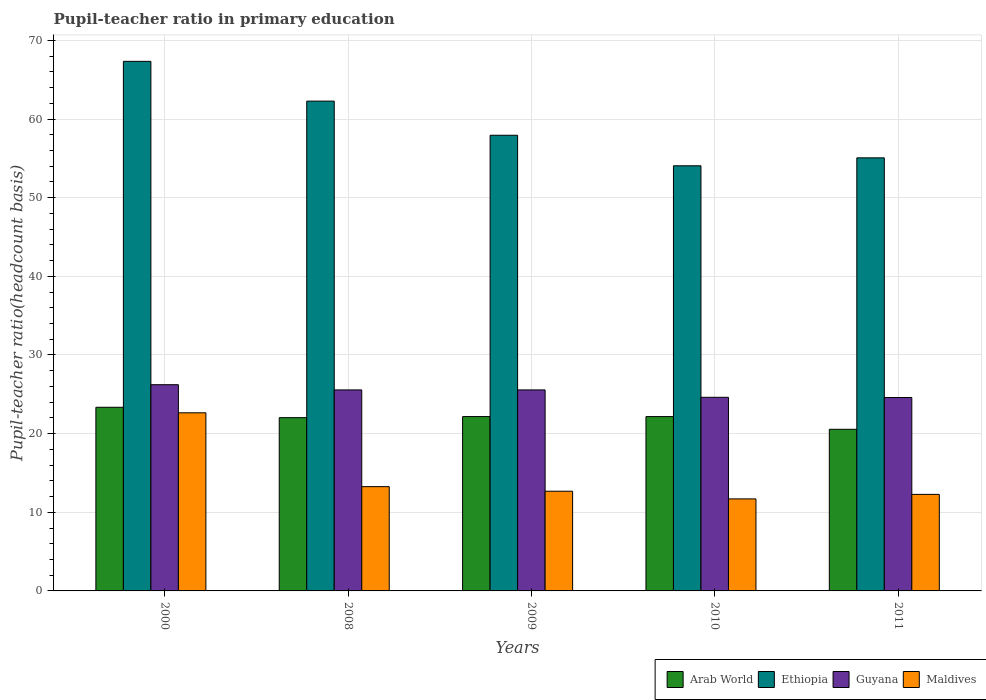How many different coloured bars are there?
Give a very brief answer. 4. How many groups of bars are there?
Ensure brevity in your answer.  5. How many bars are there on the 1st tick from the left?
Your answer should be compact. 4. What is the label of the 2nd group of bars from the left?
Provide a succinct answer. 2008. What is the pupil-teacher ratio in primary education in Guyana in 2008?
Offer a very short reply. 25.56. Across all years, what is the maximum pupil-teacher ratio in primary education in Ethiopia?
Ensure brevity in your answer.  67.34. Across all years, what is the minimum pupil-teacher ratio in primary education in Maldives?
Your answer should be very brief. 11.7. What is the total pupil-teacher ratio in primary education in Maldives in the graph?
Provide a short and direct response. 72.56. What is the difference between the pupil-teacher ratio in primary education in Ethiopia in 2000 and that in 2010?
Ensure brevity in your answer.  13.28. What is the difference between the pupil-teacher ratio in primary education in Ethiopia in 2008 and the pupil-teacher ratio in primary education in Maldives in 2009?
Your answer should be very brief. 49.61. What is the average pupil-teacher ratio in primary education in Maldives per year?
Make the answer very short. 14.51. In the year 2009, what is the difference between the pupil-teacher ratio in primary education in Ethiopia and pupil-teacher ratio in primary education in Arab World?
Your answer should be compact. 35.77. In how many years, is the pupil-teacher ratio in primary education in Guyana greater than 50?
Give a very brief answer. 0. What is the ratio of the pupil-teacher ratio in primary education in Arab World in 2000 to that in 2009?
Provide a succinct answer. 1.05. What is the difference between the highest and the second highest pupil-teacher ratio in primary education in Ethiopia?
Your answer should be compact. 5.06. What is the difference between the highest and the lowest pupil-teacher ratio in primary education in Arab World?
Your response must be concise. 2.8. In how many years, is the pupil-teacher ratio in primary education in Arab World greater than the average pupil-teacher ratio in primary education in Arab World taken over all years?
Your answer should be compact. 3. Is the sum of the pupil-teacher ratio in primary education in Arab World in 2009 and 2011 greater than the maximum pupil-teacher ratio in primary education in Ethiopia across all years?
Your answer should be compact. No. Is it the case that in every year, the sum of the pupil-teacher ratio in primary education in Ethiopia and pupil-teacher ratio in primary education in Maldives is greater than the sum of pupil-teacher ratio in primary education in Guyana and pupil-teacher ratio in primary education in Arab World?
Your answer should be compact. Yes. What does the 3rd bar from the left in 2011 represents?
Your answer should be very brief. Guyana. What does the 1st bar from the right in 2010 represents?
Keep it short and to the point. Maldives. Is it the case that in every year, the sum of the pupil-teacher ratio in primary education in Guyana and pupil-teacher ratio in primary education in Maldives is greater than the pupil-teacher ratio in primary education in Arab World?
Offer a terse response. Yes. How many bars are there?
Your response must be concise. 20. What is the difference between two consecutive major ticks on the Y-axis?
Ensure brevity in your answer.  10. Are the values on the major ticks of Y-axis written in scientific E-notation?
Provide a succinct answer. No. Does the graph contain grids?
Give a very brief answer. Yes. How are the legend labels stacked?
Keep it short and to the point. Horizontal. What is the title of the graph?
Offer a terse response. Pupil-teacher ratio in primary education. Does "Greece" appear as one of the legend labels in the graph?
Provide a short and direct response. No. What is the label or title of the X-axis?
Keep it short and to the point. Years. What is the label or title of the Y-axis?
Ensure brevity in your answer.  Pupil-teacher ratio(headcount basis). What is the Pupil-teacher ratio(headcount basis) of Arab World in 2000?
Provide a short and direct response. 23.35. What is the Pupil-teacher ratio(headcount basis) of Ethiopia in 2000?
Your answer should be compact. 67.34. What is the Pupil-teacher ratio(headcount basis) of Guyana in 2000?
Provide a succinct answer. 26.22. What is the Pupil-teacher ratio(headcount basis) in Maldives in 2000?
Ensure brevity in your answer.  22.65. What is the Pupil-teacher ratio(headcount basis) in Arab World in 2008?
Offer a very short reply. 22.03. What is the Pupil-teacher ratio(headcount basis) of Ethiopia in 2008?
Provide a succinct answer. 62.28. What is the Pupil-teacher ratio(headcount basis) in Guyana in 2008?
Keep it short and to the point. 25.56. What is the Pupil-teacher ratio(headcount basis) of Maldives in 2008?
Provide a succinct answer. 13.26. What is the Pupil-teacher ratio(headcount basis) of Arab World in 2009?
Your answer should be compact. 22.17. What is the Pupil-teacher ratio(headcount basis) in Ethiopia in 2009?
Ensure brevity in your answer.  57.94. What is the Pupil-teacher ratio(headcount basis) in Guyana in 2009?
Make the answer very short. 25.56. What is the Pupil-teacher ratio(headcount basis) of Maldives in 2009?
Provide a short and direct response. 12.68. What is the Pupil-teacher ratio(headcount basis) in Arab World in 2010?
Keep it short and to the point. 22.17. What is the Pupil-teacher ratio(headcount basis) in Ethiopia in 2010?
Offer a terse response. 54.06. What is the Pupil-teacher ratio(headcount basis) of Guyana in 2010?
Provide a short and direct response. 24.62. What is the Pupil-teacher ratio(headcount basis) in Maldives in 2010?
Give a very brief answer. 11.7. What is the Pupil-teacher ratio(headcount basis) in Arab World in 2011?
Give a very brief answer. 20.55. What is the Pupil-teacher ratio(headcount basis) of Ethiopia in 2011?
Make the answer very short. 55.07. What is the Pupil-teacher ratio(headcount basis) in Guyana in 2011?
Provide a succinct answer. 24.59. What is the Pupil-teacher ratio(headcount basis) of Maldives in 2011?
Keep it short and to the point. 12.28. Across all years, what is the maximum Pupil-teacher ratio(headcount basis) of Arab World?
Offer a very short reply. 23.35. Across all years, what is the maximum Pupil-teacher ratio(headcount basis) of Ethiopia?
Your answer should be compact. 67.34. Across all years, what is the maximum Pupil-teacher ratio(headcount basis) in Guyana?
Provide a succinct answer. 26.22. Across all years, what is the maximum Pupil-teacher ratio(headcount basis) in Maldives?
Give a very brief answer. 22.65. Across all years, what is the minimum Pupil-teacher ratio(headcount basis) of Arab World?
Offer a very short reply. 20.55. Across all years, what is the minimum Pupil-teacher ratio(headcount basis) in Ethiopia?
Ensure brevity in your answer.  54.06. Across all years, what is the minimum Pupil-teacher ratio(headcount basis) in Guyana?
Provide a succinct answer. 24.59. Across all years, what is the minimum Pupil-teacher ratio(headcount basis) in Maldives?
Your answer should be compact. 11.7. What is the total Pupil-teacher ratio(headcount basis) in Arab World in the graph?
Offer a very short reply. 110.28. What is the total Pupil-teacher ratio(headcount basis) in Ethiopia in the graph?
Your answer should be compact. 296.69. What is the total Pupil-teacher ratio(headcount basis) of Guyana in the graph?
Ensure brevity in your answer.  126.56. What is the total Pupil-teacher ratio(headcount basis) of Maldives in the graph?
Your response must be concise. 72.56. What is the difference between the Pupil-teacher ratio(headcount basis) of Arab World in 2000 and that in 2008?
Your response must be concise. 1.32. What is the difference between the Pupil-teacher ratio(headcount basis) in Ethiopia in 2000 and that in 2008?
Provide a succinct answer. 5.06. What is the difference between the Pupil-teacher ratio(headcount basis) of Guyana in 2000 and that in 2008?
Offer a terse response. 0.66. What is the difference between the Pupil-teacher ratio(headcount basis) in Maldives in 2000 and that in 2008?
Offer a very short reply. 9.39. What is the difference between the Pupil-teacher ratio(headcount basis) in Arab World in 2000 and that in 2009?
Make the answer very short. 1.18. What is the difference between the Pupil-teacher ratio(headcount basis) of Ethiopia in 2000 and that in 2009?
Ensure brevity in your answer.  9.4. What is the difference between the Pupil-teacher ratio(headcount basis) of Guyana in 2000 and that in 2009?
Your answer should be very brief. 0.66. What is the difference between the Pupil-teacher ratio(headcount basis) in Maldives in 2000 and that in 2009?
Provide a succinct answer. 9.97. What is the difference between the Pupil-teacher ratio(headcount basis) in Arab World in 2000 and that in 2010?
Offer a very short reply. 1.19. What is the difference between the Pupil-teacher ratio(headcount basis) in Ethiopia in 2000 and that in 2010?
Offer a terse response. 13.28. What is the difference between the Pupil-teacher ratio(headcount basis) of Guyana in 2000 and that in 2010?
Offer a terse response. 1.6. What is the difference between the Pupil-teacher ratio(headcount basis) of Maldives in 2000 and that in 2010?
Your answer should be very brief. 10.95. What is the difference between the Pupil-teacher ratio(headcount basis) in Arab World in 2000 and that in 2011?
Your answer should be very brief. 2.8. What is the difference between the Pupil-teacher ratio(headcount basis) of Ethiopia in 2000 and that in 2011?
Offer a very short reply. 12.27. What is the difference between the Pupil-teacher ratio(headcount basis) in Guyana in 2000 and that in 2011?
Your response must be concise. 1.63. What is the difference between the Pupil-teacher ratio(headcount basis) of Maldives in 2000 and that in 2011?
Provide a short and direct response. 10.37. What is the difference between the Pupil-teacher ratio(headcount basis) in Arab World in 2008 and that in 2009?
Provide a short and direct response. -0.14. What is the difference between the Pupil-teacher ratio(headcount basis) of Ethiopia in 2008 and that in 2009?
Your answer should be compact. 4.34. What is the difference between the Pupil-teacher ratio(headcount basis) in Guyana in 2008 and that in 2009?
Provide a short and direct response. -0. What is the difference between the Pupil-teacher ratio(headcount basis) of Maldives in 2008 and that in 2009?
Offer a terse response. 0.58. What is the difference between the Pupil-teacher ratio(headcount basis) in Arab World in 2008 and that in 2010?
Provide a short and direct response. -0.14. What is the difference between the Pupil-teacher ratio(headcount basis) of Ethiopia in 2008 and that in 2010?
Offer a terse response. 8.22. What is the difference between the Pupil-teacher ratio(headcount basis) in Guyana in 2008 and that in 2010?
Provide a succinct answer. 0.94. What is the difference between the Pupil-teacher ratio(headcount basis) of Maldives in 2008 and that in 2010?
Your answer should be very brief. 1.56. What is the difference between the Pupil-teacher ratio(headcount basis) in Arab World in 2008 and that in 2011?
Keep it short and to the point. 1.48. What is the difference between the Pupil-teacher ratio(headcount basis) in Ethiopia in 2008 and that in 2011?
Ensure brevity in your answer.  7.21. What is the difference between the Pupil-teacher ratio(headcount basis) of Guyana in 2008 and that in 2011?
Keep it short and to the point. 0.97. What is the difference between the Pupil-teacher ratio(headcount basis) of Maldives in 2008 and that in 2011?
Provide a succinct answer. 0.98. What is the difference between the Pupil-teacher ratio(headcount basis) of Arab World in 2009 and that in 2010?
Offer a terse response. 0. What is the difference between the Pupil-teacher ratio(headcount basis) in Ethiopia in 2009 and that in 2010?
Provide a short and direct response. 3.88. What is the difference between the Pupil-teacher ratio(headcount basis) of Maldives in 2009 and that in 2010?
Offer a terse response. 0.98. What is the difference between the Pupil-teacher ratio(headcount basis) in Arab World in 2009 and that in 2011?
Ensure brevity in your answer.  1.62. What is the difference between the Pupil-teacher ratio(headcount basis) in Ethiopia in 2009 and that in 2011?
Offer a very short reply. 2.87. What is the difference between the Pupil-teacher ratio(headcount basis) in Guyana in 2009 and that in 2011?
Make the answer very short. 0.97. What is the difference between the Pupil-teacher ratio(headcount basis) in Maldives in 2009 and that in 2011?
Offer a terse response. 0.4. What is the difference between the Pupil-teacher ratio(headcount basis) in Arab World in 2010 and that in 2011?
Ensure brevity in your answer.  1.61. What is the difference between the Pupil-teacher ratio(headcount basis) in Ethiopia in 2010 and that in 2011?
Offer a very short reply. -1.01. What is the difference between the Pupil-teacher ratio(headcount basis) in Guyana in 2010 and that in 2011?
Make the answer very short. 0.03. What is the difference between the Pupil-teacher ratio(headcount basis) of Maldives in 2010 and that in 2011?
Offer a terse response. -0.57. What is the difference between the Pupil-teacher ratio(headcount basis) in Arab World in 2000 and the Pupil-teacher ratio(headcount basis) in Ethiopia in 2008?
Offer a very short reply. -38.93. What is the difference between the Pupil-teacher ratio(headcount basis) of Arab World in 2000 and the Pupil-teacher ratio(headcount basis) of Guyana in 2008?
Your answer should be compact. -2.21. What is the difference between the Pupil-teacher ratio(headcount basis) of Arab World in 2000 and the Pupil-teacher ratio(headcount basis) of Maldives in 2008?
Your answer should be very brief. 10.09. What is the difference between the Pupil-teacher ratio(headcount basis) in Ethiopia in 2000 and the Pupil-teacher ratio(headcount basis) in Guyana in 2008?
Offer a terse response. 41.78. What is the difference between the Pupil-teacher ratio(headcount basis) in Ethiopia in 2000 and the Pupil-teacher ratio(headcount basis) in Maldives in 2008?
Ensure brevity in your answer.  54.08. What is the difference between the Pupil-teacher ratio(headcount basis) in Guyana in 2000 and the Pupil-teacher ratio(headcount basis) in Maldives in 2008?
Your response must be concise. 12.97. What is the difference between the Pupil-teacher ratio(headcount basis) in Arab World in 2000 and the Pupil-teacher ratio(headcount basis) in Ethiopia in 2009?
Keep it short and to the point. -34.59. What is the difference between the Pupil-teacher ratio(headcount basis) in Arab World in 2000 and the Pupil-teacher ratio(headcount basis) in Guyana in 2009?
Provide a short and direct response. -2.21. What is the difference between the Pupil-teacher ratio(headcount basis) of Arab World in 2000 and the Pupil-teacher ratio(headcount basis) of Maldives in 2009?
Keep it short and to the point. 10.68. What is the difference between the Pupil-teacher ratio(headcount basis) in Ethiopia in 2000 and the Pupil-teacher ratio(headcount basis) in Guyana in 2009?
Offer a terse response. 41.78. What is the difference between the Pupil-teacher ratio(headcount basis) of Ethiopia in 2000 and the Pupil-teacher ratio(headcount basis) of Maldives in 2009?
Keep it short and to the point. 54.66. What is the difference between the Pupil-teacher ratio(headcount basis) of Guyana in 2000 and the Pupil-teacher ratio(headcount basis) of Maldives in 2009?
Offer a terse response. 13.55. What is the difference between the Pupil-teacher ratio(headcount basis) in Arab World in 2000 and the Pupil-teacher ratio(headcount basis) in Ethiopia in 2010?
Your response must be concise. -30.71. What is the difference between the Pupil-teacher ratio(headcount basis) of Arab World in 2000 and the Pupil-teacher ratio(headcount basis) of Guyana in 2010?
Provide a short and direct response. -1.27. What is the difference between the Pupil-teacher ratio(headcount basis) of Arab World in 2000 and the Pupil-teacher ratio(headcount basis) of Maldives in 2010?
Provide a succinct answer. 11.65. What is the difference between the Pupil-teacher ratio(headcount basis) in Ethiopia in 2000 and the Pupil-teacher ratio(headcount basis) in Guyana in 2010?
Offer a terse response. 42.72. What is the difference between the Pupil-teacher ratio(headcount basis) in Ethiopia in 2000 and the Pupil-teacher ratio(headcount basis) in Maldives in 2010?
Your answer should be compact. 55.64. What is the difference between the Pupil-teacher ratio(headcount basis) in Guyana in 2000 and the Pupil-teacher ratio(headcount basis) in Maldives in 2010?
Provide a short and direct response. 14.52. What is the difference between the Pupil-teacher ratio(headcount basis) of Arab World in 2000 and the Pupil-teacher ratio(headcount basis) of Ethiopia in 2011?
Offer a terse response. -31.72. What is the difference between the Pupil-teacher ratio(headcount basis) in Arab World in 2000 and the Pupil-teacher ratio(headcount basis) in Guyana in 2011?
Give a very brief answer. -1.24. What is the difference between the Pupil-teacher ratio(headcount basis) of Arab World in 2000 and the Pupil-teacher ratio(headcount basis) of Maldives in 2011?
Keep it short and to the point. 11.08. What is the difference between the Pupil-teacher ratio(headcount basis) in Ethiopia in 2000 and the Pupil-teacher ratio(headcount basis) in Guyana in 2011?
Your response must be concise. 42.75. What is the difference between the Pupil-teacher ratio(headcount basis) in Ethiopia in 2000 and the Pupil-teacher ratio(headcount basis) in Maldives in 2011?
Make the answer very short. 55.06. What is the difference between the Pupil-teacher ratio(headcount basis) of Guyana in 2000 and the Pupil-teacher ratio(headcount basis) of Maldives in 2011?
Provide a short and direct response. 13.95. What is the difference between the Pupil-teacher ratio(headcount basis) of Arab World in 2008 and the Pupil-teacher ratio(headcount basis) of Ethiopia in 2009?
Offer a terse response. -35.91. What is the difference between the Pupil-teacher ratio(headcount basis) in Arab World in 2008 and the Pupil-teacher ratio(headcount basis) in Guyana in 2009?
Your response must be concise. -3.53. What is the difference between the Pupil-teacher ratio(headcount basis) of Arab World in 2008 and the Pupil-teacher ratio(headcount basis) of Maldives in 2009?
Provide a short and direct response. 9.35. What is the difference between the Pupil-teacher ratio(headcount basis) in Ethiopia in 2008 and the Pupil-teacher ratio(headcount basis) in Guyana in 2009?
Ensure brevity in your answer.  36.72. What is the difference between the Pupil-teacher ratio(headcount basis) of Ethiopia in 2008 and the Pupil-teacher ratio(headcount basis) of Maldives in 2009?
Ensure brevity in your answer.  49.61. What is the difference between the Pupil-teacher ratio(headcount basis) of Guyana in 2008 and the Pupil-teacher ratio(headcount basis) of Maldives in 2009?
Provide a succinct answer. 12.88. What is the difference between the Pupil-teacher ratio(headcount basis) of Arab World in 2008 and the Pupil-teacher ratio(headcount basis) of Ethiopia in 2010?
Keep it short and to the point. -32.03. What is the difference between the Pupil-teacher ratio(headcount basis) of Arab World in 2008 and the Pupil-teacher ratio(headcount basis) of Guyana in 2010?
Give a very brief answer. -2.59. What is the difference between the Pupil-teacher ratio(headcount basis) of Arab World in 2008 and the Pupil-teacher ratio(headcount basis) of Maldives in 2010?
Your answer should be very brief. 10.33. What is the difference between the Pupil-teacher ratio(headcount basis) of Ethiopia in 2008 and the Pupil-teacher ratio(headcount basis) of Guyana in 2010?
Make the answer very short. 37.66. What is the difference between the Pupil-teacher ratio(headcount basis) in Ethiopia in 2008 and the Pupil-teacher ratio(headcount basis) in Maldives in 2010?
Your answer should be compact. 50.58. What is the difference between the Pupil-teacher ratio(headcount basis) in Guyana in 2008 and the Pupil-teacher ratio(headcount basis) in Maldives in 2010?
Provide a succinct answer. 13.86. What is the difference between the Pupil-teacher ratio(headcount basis) in Arab World in 2008 and the Pupil-teacher ratio(headcount basis) in Ethiopia in 2011?
Ensure brevity in your answer.  -33.04. What is the difference between the Pupil-teacher ratio(headcount basis) of Arab World in 2008 and the Pupil-teacher ratio(headcount basis) of Guyana in 2011?
Ensure brevity in your answer.  -2.56. What is the difference between the Pupil-teacher ratio(headcount basis) in Arab World in 2008 and the Pupil-teacher ratio(headcount basis) in Maldives in 2011?
Offer a terse response. 9.76. What is the difference between the Pupil-teacher ratio(headcount basis) in Ethiopia in 2008 and the Pupil-teacher ratio(headcount basis) in Guyana in 2011?
Provide a short and direct response. 37.69. What is the difference between the Pupil-teacher ratio(headcount basis) of Ethiopia in 2008 and the Pupil-teacher ratio(headcount basis) of Maldives in 2011?
Your answer should be compact. 50.01. What is the difference between the Pupil-teacher ratio(headcount basis) in Guyana in 2008 and the Pupil-teacher ratio(headcount basis) in Maldives in 2011?
Your response must be concise. 13.29. What is the difference between the Pupil-teacher ratio(headcount basis) in Arab World in 2009 and the Pupil-teacher ratio(headcount basis) in Ethiopia in 2010?
Keep it short and to the point. -31.89. What is the difference between the Pupil-teacher ratio(headcount basis) of Arab World in 2009 and the Pupil-teacher ratio(headcount basis) of Guyana in 2010?
Give a very brief answer. -2.45. What is the difference between the Pupil-teacher ratio(headcount basis) of Arab World in 2009 and the Pupil-teacher ratio(headcount basis) of Maldives in 2010?
Keep it short and to the point. 10.47. What is the difference between the Pupil-teacher ratio(headcount basis) of Ethiopia in 2009 and the Pupil-teacher ratio(headcount basis) of Guyana in 2010?
Your answer should be very brief. 33.32. What is the difference between the Pupil-teacher ratio(headcount basis) of Ethiopia in 2009 and the Pupil-teacher ratio(headcount basis) of Maldives in 2010?
Your answer should be compact. 46.24. What is the difference between the Pupil-teacher ratio(headcount basis) of Guyana in 2009 and the Pupil-teacher ratio(headcount basis) of Maldives in 2010?
Ensure brevity in your answer.  13.86. What is the difference between the Pupil-teacher ratio(headcount basis) in Arab World in 2009 and the Pupil-teacher ratio(headcount basis) in Ethiopia in 2011?
Give a very brief answer. -32.9. What is the difference between the Pupil-teacher ratio(headcount basis) in Arab World in 2009 and the Pupil-teacher ratio(headcount basis) in Guyana in 2011?
Ensure brevity in your answer.  -2.42. What is the difference between the Pupil-teacher ratio(headcount basis) of Arab World in 2009 and the Pupil-teacher ratio(headcount basis) of Maldives in 2011?
Provide a short and direct response. 9.9. What is the difference between the Pupil-teacher ratio(headcount basis) in Ethiopia in 2009 and the Pupil-teacher ratio(headcount basis) in Guyana in 2011?
Provide a succinct answer. 33.35. What is the difference between the Pupil-teacher ratio(headcount basis) in Ethiopia in 2009 and the Pupil-teacher ratio(headcount basis) in Maldives in 2011?
Keep it short and to the point. 45.67. What is the difference between the Pupil-teacher ratio(headcount basis) of Guyana in 2009 and the Pupil-teacher ratio(headcount basis) of Maldives in 2011?
Provide a short and direct response. 13.29. What is the difference between the Pupil-teacher ratio(headcount basis) in Arab World in 2010 and the Pupil-teacher ratio(headcount basis) in Ethiopia in 2011?
Ensure brevity in your answer.  -32.9. What is the difference between the Pupil-teacher ratio(headcount basis) in Arab World in 2010 and the Pupil-teacher ratio(headcount basis) in Guyana in 2011?
Offer a terse response. -2.42. What is the difference between the Pupil-teacher ratio(headcount basis) of Arab World in 2010 and the Pupil-teacher ratio(headcount basis) of Maldives in 2011?
Make the answer very short. 9.89. What is the difference between the Pupil-teacher ratio(headcount basis) in Ethiopia in 2010 and the Pupil-teacher ratio(headcount basis) in Guyana in 2011?
Make the answer very short. 29.47. What is the difference between the Pupil-teacher ratio(headcount basis) of Ethiopia in 2010 and the Pupil-teacher ratio(headcount basis) of Maldives in 2011?
Ensure brevity in your answer.  41.78. What is the difference between the Pupil-teacher ratio(headcount basis) of Guyana in 2010 and the Pupil-teacher ratio(headcount basis) of Maldives in 2011?
Make the answer very short. 12.34. What is the average Pupil-teacher ratio(headcount basis) of Arab World per year?
Keep it short and to the point. 22.06. What is the average Pupil-teacher ratio(headcount basis) of Ethiopia per year?
Offer a terse response. 59.34. What is the average Pupil-teacher ratio(headcount basis) of Guyana per year?
Give a very brief answer. 25.31. What is the average Pupil-teacher ratio(headcount basis) in Maldives per year?
Your answer should be compact. 14.51. In the year 2000, what is the difference between the Pupil-teacher ratio(headcount basis) in Arab World and Pupil-teacher ratio(headcount basis) in Ethiopia?
Offer a terse response. -43.99. In the year 2000, what is the difference between the Pupil-teacher ratio(headcount basis) of Arab World and Pupil-teacher ratio(headcount basis) of Guyana?
Give a very brief answer. -2.87. In the year 2000, what is the difference between the Pupil-teacher ratio(headcount basis) of Arab World and Pupil-teacher ratio(headcount basis) of Maldives?
Make the answer very short. 0.7. In the year 2000, what is the difference between the Pupil-teacher ratio(headcount basis) in Ethiopia and Pupil-teacher ratio(headcount basis) in Guyana?
Give a very brief answer. 41.11. In the year 2000, what is the difference between the Pupil-teacher ratio(headcount basis) in Ethiopia and Pupil-teacher ratio(headcount basis) in Maldives?
Your answer should be very brief. 44.69. In the year 2000, what is the difference between the Pupil-teacher ratio(headcount basis) in Guyana and Pupil-teacher ratio(headcount basis) in Maldives?
Your response must be concise. 3.57. In the year 2008, what is the difference between the Pupil-teacher ratio(headcount basis) in Arab World and Pupil-teacher ratio(headcount basis) in Ethiopia?
Give a very brief answer. -40.25. In the year 2008, what is the difference between the Pupil-teacher ratio(headcount basis) in Arab World and Pupil-teacher ratio(headcount basis) in Guyana?
Offer a terse response. -3.53. In the year 2008, what is the difference between the Pupil-teacher ratio(headcount basis) of Arab World and Pupil-teacher ratio(headcount basis) of Maldives?
Offer a terse response. 8.77. In the year 2008, what is the difference between the Pupil-teacher ratio(headcount basis) in Ethiopia and Pupil-teacher ratio(headcount basis) in Guyana?
Your answer should be very brief. 36.72. In the year 2008, what is the difference between the Pupil-teacher ratio(headcount basis) of Ethiopia and Pupil-teacher ratio(headcount basis) of Maldives?
Your answer should be compact. 49.02. In the year 2008, what is the difference between the Pupil-teacher ratio(headcount basis) in Guyana and Pupil-teacher ratio(headcount basis) in Maldives?
Offer a very short reply. 12.3. In the year 2009, what is the difference between the Pupil-teacher ratio(headcount basis) in Arab World and Pupil-teacher ratio(headcount basis) in Ethiopia?
Offer a very short reply. -35.77. In the year 2009, what is the difference between the Pupil-teacher ratio(headcount basis) in Arab World and Pupil-teacher ratio(headcount basis) in Guyana?
Provide a short and direct response. -3.39. In the year 2009, what is the difference between the Pupil-teacher ratio(headcount basis) of Arab World and Pupil-teacher ratio(headcount basis) of Maldives?
Give a very brief answer. 9.49. In the year 2009, what is the difference between the Pupil-teacher ratio(headcount basis) in Ethiopia and Pupil-teacher ratio(headcount basis) in Guyana?
Provide a short and direct response. 32.38. In the year 2009, what is the difference between the Pupil-teacher ratio(headcount basis) of Ethiopia and Pupil-teacher ratio(headcount basis) of Maldives?
Give a very brief answer. 45.26. In the year 2009, what is the difference between the Pupil-teacher ratio(headcount basis) of Guyana and Pupil-teacher ratio(headcount basis) of Maldives?
Your answer should be compact. 12.88. In the year 2010, what is the difference between the Pupil-teacher ratio(headcount basis) in Arab World and Pupil-teacher ratio(headcount basis) in Ethiopia?
Offer a terse response. -31.89. In the year 2010, what is the difference between the Pupil-teacher ratio(headcount basis) of Arab World and Pupil-teacher ratio(headcount basis) of Guyana?
Offer a very short reply. -2.45. In the year 2010, what is the difference between the Pupil-teacher ratio(headcount basis) in Arab World and Pupil-teacher ratio(headcount basis) in Maldives?
Offer a terse response. 10.47. In the year 2010, what is the difference between the Pupil-teacher ratio(headcount basis) in Ethiopia and Pupil-teacher ratio(headcount basis) in Guyana?
Offer a terse response. 29.44. In the year 2010, what is the difference between the Pupil-teacher ratio(headcount basis) in Ethiopia and Pupil-teacher ratio(headcount basis) in Maldives?
Keep it short and to the point. 42.36. In the year 2010, what is the difference between the Pupil-teacher ratio(headcount basis) in Guyana and Pupil-teacher ratio(headcount basis) in Maldives?
Give a very brief answer. 12.92. In the year 2011, what is the difference between the Pupil-teacher ratio(headcount basis) of Arab World and Pupil-teacher ratio(headcount basis) of Ethiopia?
Make the answer very short. -34.52. In the year 2011, what is the difference between the Pupil-teacher ratio(headcount basis) of Arab World and Pupil-teacher ratio(headcount basis) of Guyana?
Provide a succinct answer. -4.04. In the year 2011, what is the difference between the Pupil-teacher ratio(headcount basis) in Arab World and Pupil-teacher ratio(headcount basis) in Maldives?
Ensure brevity in your answer.  8.28. In the year 2011, what is the difference between the Pupil-teacher ratio(headcount basis) of Ethiopia and Pupil-teacher ratio(headcount basis) of Guyana?
Ensure brevity in your answer.  30.48. In the year 2011, what is the difference between the Pupil-teacher ratio(headcount basis) in Ethiopia and Pupil-teacher ratio(headcount basis) in Maldives?
Provide a succinct answer. 42.79. In the year 2011, what is the difference between the Pupil-teacher ratio(headcount basis) in Guyana and Pupil-teacher ratio(headcount basis) in Maldives?
Provide a short and direct response. 12.32. What is the ratio of the Pupil-teacher ratio(headcount basis) of Arab World in 2000 to that in 2008?
Offer a very short reply. 1.06. What is the ratio of the Pupil-teacher ratio(headcount basis) of Ethiopia in 2000 to that in 2008?
Provide a short and direct response. 1.08. What is the ratio of the Pupil-teacher ratio(headcount basis) in Maldives in 2000 to that in 2008?
Make the answer very short. 1.71. What is the ratio of the Pupil-teacher ratio(headcount basis) of Arab World in 2000 to that in 2009?
Offer a terse response. 1.05. What is the ratio of the Pupil-teacher ratio(headcount basis) in Ethiopia in 2000 to that in 2009?
Your response must be concise. 1.16. What is the ratio of the Pupil-teacher ratio(headcount basis) of Guyana in 2000 to that in 2009?
Keep it short and to the point. 1.03. What is the ratio of the Pupil-teacher ratio(headcount basis) of Maldives in 2000 to that in 2009?
Provide a short and direct response. 1.79. What is the ratio of the Pupil-teacher ratio(headcount basis) of Arab World in 2000 to that in 2010?
Your response must be concise. 1.05. What is the ratio of the Pupil-teacher ratio(headcount basis) in Ethiopia in 2000 to that in 2010?
Provide a short and direct response. 1.25. What is the ratio of the Pupil-teacher ratio(headcount basis) of Guyana in 2000 to that in 2010?
Provide a short and direct response. 1.07. What is the ratio of the Pupil-teacher ratio(headcount basis) of Maldives in 2000 to that in 2010?
Keep it short and to the point. 1.94. What is the ratio of the Pupil-teacher ratio(headcount basis) in Arab World in 2000 to that in 2011?
Provide a short and direct response. 1.14. What is the ratio of the Pupil-teacher ratio(headcount basis) of Ethiopia in 2000 to that in 2011?
Give a very brief answer. 1.22. What is the ratio of the Pupil-teacher ratio(headcount basis) of Guyana in 2000 to that in 2011?
Offer a very short reply. 1.07. What is the ratio of the Pupil-teacher ratio(headcount basis) in Maldives in 2000 to that in 2011?
Provide a short and direct response. 1.85. What is the ratio of the Pupil-teacher ratio(headcount basis) of Ethiopia in 2008 to that in 2009?
Ensure brevity in your answer.  1.07. What is the ratio of the Pupil-teacher ratio(headcount basis) of Maldives in 2008 to that in 2009?
Provide a short and direct response. 1.05. What is the ratio of the Pupil-teacher ratio(headcount basis) of Arab World in 2008 to that in 2010?
Your answer should be compact. 0.99. What is the ratio of the Pupil-teacher ratio(headcount basis) in Ethiopia in 2008 to that in 2010?
Offer a very short reply. 1.15. What is the ratio of the Pupil-teacher ratio(headcount basis) of Guyana in 2008 to that in 2010?
Give a very brief answer. 1.04. What is the ratio of the Pupil-teacher ratio(headcount basis) in Maldives in 2008 to that in 2010?
Your response must be concise. 1.13. What is the ratio of the Pupil-teacher ratio(headcount basis) in Arab World in 2008 to that in 2011?
Provide a short and direct response. 1.07. What is the ratio of the Pupil-teacher ratio(headcount basis) in Ethiopia in 2008 to that in 2011?
Offer a terse response. 1.13. What is the ratio of the Pupil-teacher ratio(headcount basis) of Guyana in 2008 to that in 2011?
Offer a very short reply. 1.04. What is the ratio of the Pupil-teacher ratio(headcount basis) of Maldives in 2008 to that in 2011?
Your response must be concise. 1.08. What is the ratio of the Pupil-teacher ratio(headcount basis) in Arab World in 2009 to that in 2010?
Keep it short and to the point. 1. What is the ratio of the Pupil-teacher ratio(headcount basis) of Ethiopia in 2009 to that in 2010?
Your answer should be very brief. 1.07. What is the ratio of the Pupil-teacher ratio(headcount basis) in Guyana in 2009 to that in 2010?
Keep it short and to the point. 1.04. What is the ratio of the Pupil-teacher ratio(headcount basis) of Maldives in 2009 to that in 2010?
Your answer should be compact. 1.08. What is the ratio of the Pupil-teacher ratio(headcount basis) in Arab World in 2009 to that in 2011?
Provide a succinct answer. 1.08. What is the ratio of the Pupil-teacher ratio(headcount basis) in Ethiopia in 2009 to that in 2011?
Your response must be concise. 1.05. What is the ratio of the Pupil-teacher ratio(headcount basis) of Guyana in 2009 to that in 2011?
Keep it short and to the point. 1.04. What is the ratio of the Pupil-teacher ratio(headcount basis) in Maldives in 2009 to that in 2011?
Provide a succinct answer. 1.03. What is the ratio of the Pupil-teacher ratio(headcount basis) of Arab World in 2010 to that in 2011?
Offer a very short reply. 1.08. What is the ratio of the Pupil-teacher ratio(headcount basis) of Ethiopia in 2010 to that in 2011?
Offer a terse response. 0.98. What is the ratio of the Pupil-teacher ratio(headcount basis) of Maldives in 2010 to that in 2011?
Your answer should be very brief. 0.95. What is the difference between the highest and the second highest Pupil-teacher ratio(headcount basis) in Arab World?
Your response must be concise. 1.18. What is the difference between the highest and the second highest Pupil-teacher ratio(headcount basis) of Ethiopia?
Offer a terse response. 5.06. What is the difference between the highest and the second highest Pupil-teacher ratio(headcount basis) in Guyana?
Keep it short and to the point. 0.66. What is the difference between the highest and the second highest Pupil-teacher ratio(headcount basis) in Maldives?
Your response must be concise. 9.39. What is the difference between the highest and the lowest Pupil-teacher ratio(headcount basis) in Arab World?
Your answer should be compact. 2.8. What is the difference between the highest and the lowest Pupil-teacher ratio(headcount basis) in Ethiopia?
Make the answer very short. 13.28. What is the difference between the highest and the lowest Pupil-teacher ratio(headcount basis) in Guyana?
Provide a short and direct response. 1.63. What is the difference between the highest and the lowest Pupil-teacher ratio(headcount basis) of Maldives?
Provide a succinct answer. 10.95. 